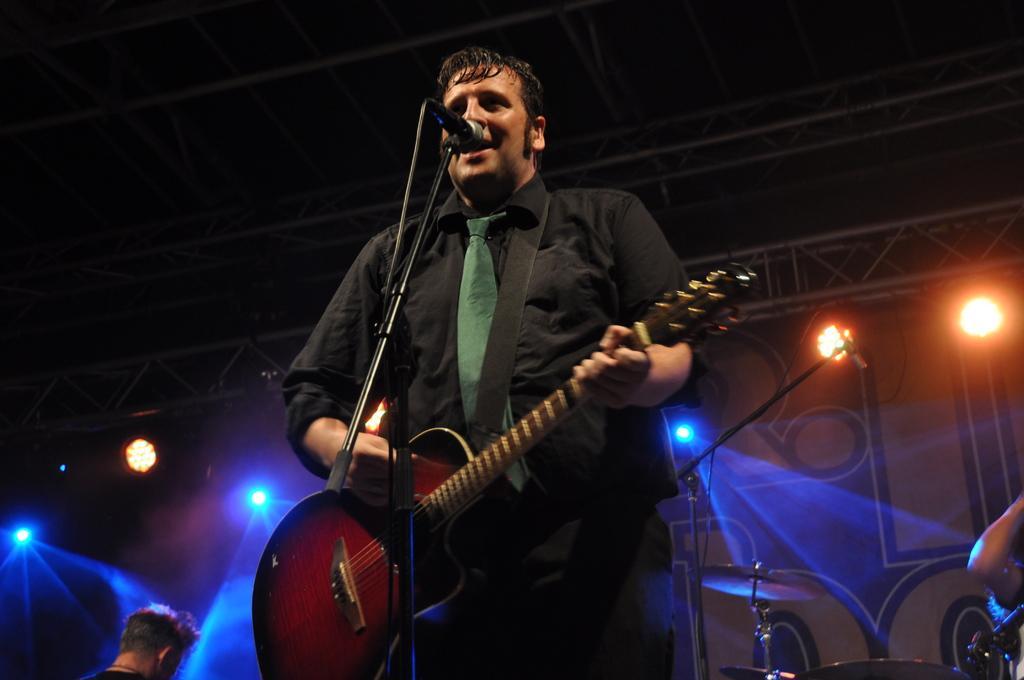Could you give a brief overview of what you see in this image? Here we see a man playing a guitar and singing with the help of a microphone 